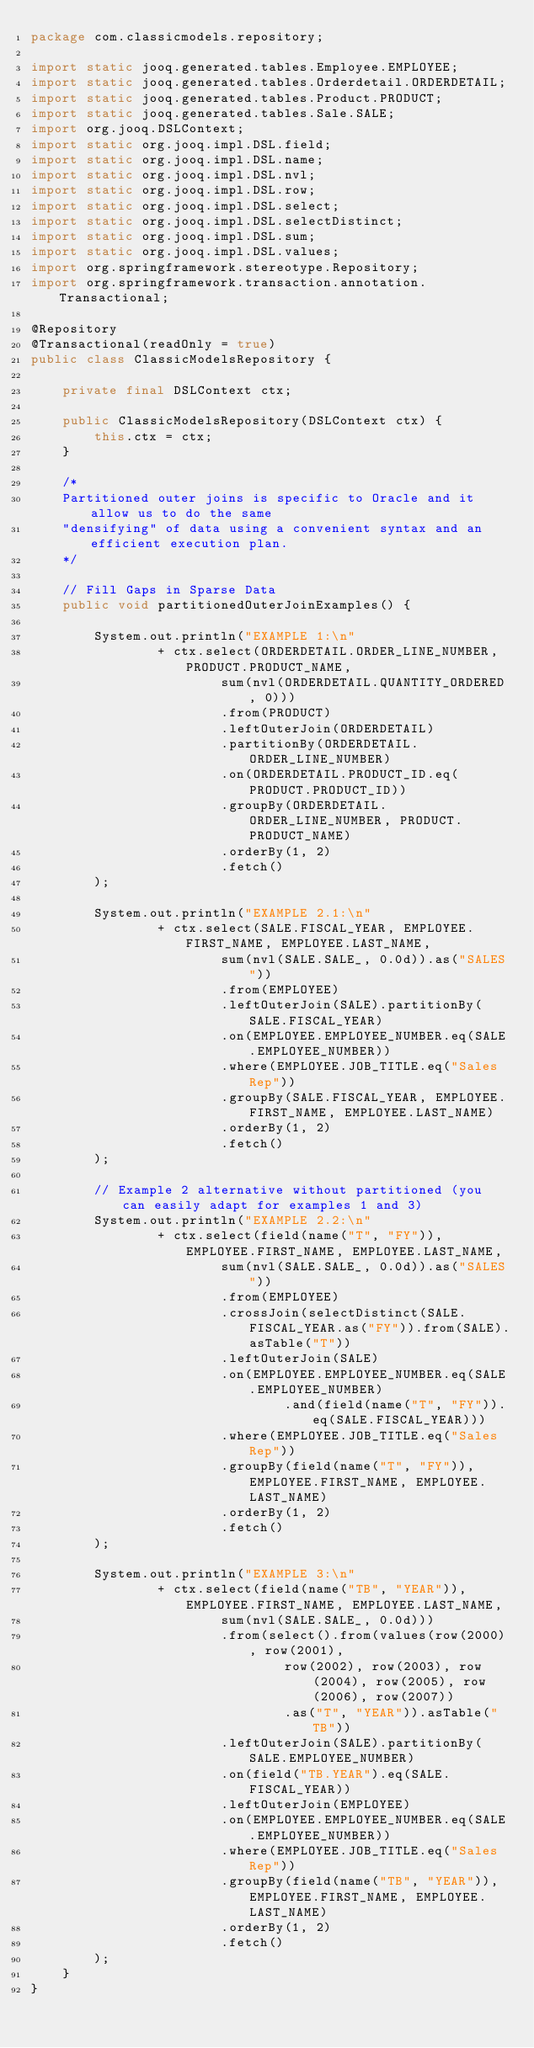<code> <loc_0><loc_0><loc_500><loc_500><_Java_>package com.classicmodels.repository;

import static jooq.generated.tables.Employee.EMPLOYEE;
import static jooq.generated.tables.Orderdetail.ORDERDETAIL;
import static jooq.generated.tables.Product.PRODUCT;
import static jooq.generated.tables.Sale.SALE;
import org.jooq.DSLContext;
import static org.jooq.impl.DSL.field;
import static org.jooq.impl.DSL.name;
import static org.jooq.impl.DSL.nvl;
import static org.jooq.impl.DSL.row;
import static org.jooq.impl.DSL.select;
import static org.jooq.impl.DSL.selectDistinct;
import static org.jooq.impl.DSL.sum;
import static org.jooq.impl.DSL.values;
import org.springframework.stereotype.Repository;
import org.springframework.transaction.annotation.Transactional;

@Repository
@Transactional(readOnly = true)
public class ClassicModelsRepository {

    private final DSLContext ctx;

    public ClassicModelsRepository(DSLContext ctx) {
        this.ctx = ctx;
    }

    /*
    Partitioned outer joins is specific to Oracle and it allow us to do the same 
    "densifying" of data using a convenient syntax and an efficient execution plan.
    */
    
    // Fill Gaps in Sparse Data
    public void partitionedOuterJoinExamples() {

        System.out.println("EXAMPLE 1:\n"
                + ctx.select(ORDERDETAIL.ORDER_LINE_NUMBER, PRODUCT.PRODUCT_NAME,
                        sum(nvl(ORDERDETAIL.QUANTITY_ORDERED, 0)))
                        .from(PRODUCT)
                        .leftOuterJoin(ORDERDETAIL)
                        .partitionBy(ORDERDETAIL.ORDER_LINE_NUMBER)
                        .on(ORDERDETAIL.PRODUCT_ID.eq(PRODUCT.PRODUCT_ID))
                        .groupBy(ORDERDETAIL.ORDER_LINE_NUMBER, PRODUCT.PRODUCT_NAME)
                        .orderBy(1, 2)
                        .fetch()
        );

        System.out.println("EXAMPLE 2.1:\n"
                + ctx.select(SALE.FISCAL_YEAR, EMPLOYEE.FIRST_NAME, EMPLOYEE.LAST_NAME,
                        sum(nvl(SALE.SALE_, 0.0d)).as("SALES"))
                        .from(EMPLOYEE)
                        .leftOuterJoin(SALE).partitionBy(SALE.FISCAL_YEAR)
                        .on(EMPLOYEE.EMPLOYEE_NUMBER.eq(SALE.EMPLOYEE_NUMBER))
                        .where(EMPLOYEE.JOB_TITLE.eq("Sales Rep"))
                        .groupBy(SALE.FISCAL_YEAR, EMPLOYEE.FIRST_NAME, EMPLOYEE.LAST_NAME)
                        .orderBy(1, 2)
                        .fetch()
        );

        // Example 2 alternative without partitioned (you can easily adapt for examples 1 and 3)
        System.out.println("EXAMPLE 2.2:\n"
                + ctx.select(field(name("T", "FY")), EMPLOYEE.FIRST_NAME, EMPLOYEE.LAST_NAME,
                        sum(nvl(SALE.SALE_, 0.0d)).as("SALES"))
                        .from(EMPLOYEE)
                        .crossJoin(selectDistinct(SALE.FISCAL_YEAR.as("FY")).from(SALE).asTable("T"))
                        .leftOuterJoin(SALE)
                        .on(EMPLOYEE.EMPLOYEE_NUMBER.eq(SALE.EMPLOYEE_NUMBER)
                                .and(field(name("T", "FY")).eq(SALE.FISCAL_YEAR)))
                        .where(EMPLOYEE.JOB_TITLE.eq("Sales Rep"))
                        .groupBy(field(name("T", "FY")), EMPLOYEE.FIRST_NAME, EMPLOYEE.LAST_NAME)
                        .orderBy(1, 2)
                        .fetch()
        );
    
        System.out.println("EXAMPLE 3:\n"
                + ctx.select(field(name("TB", "YEAR")), EMPLOYEE.FIRST_NAME, EMPLOYEE.LAST_NAME,
                        sum(nvl(SALE.SALE_, 0.0d)))
                        .from(select().from(values(row(2000), row(2001),
                                row(2002), row(2003), row(2004), row(2005), row(2006), row(2007))
                                .as("T", "YEAR")).asTable("TB"))
                        .leftOuterJoin(SALE).partitionBy(SALE.EMPLOYEE_NUMBER)
                        .on(field("TB.YEAR").eq(SALE.FISCAL_YEAR))
                        .leftOuterJoin(EMPLOYEE)
                        .on(EMPLOYEE.EMPLOYEE_NUMBER.eq(SALE.EMPLOYEE_NUMBER))
                        .where(EMPLOYEE.JOB_TITLE.eq("Sales Rep"))
                        .groupBy(field(name("TB", "YEAR")), EMPLOYEE.FIRST_NAME, EMPLOYEE.LAST_NAME)
                        .orderBy(1, 2)
                        .fetch()
        );
    }
}
</code> 